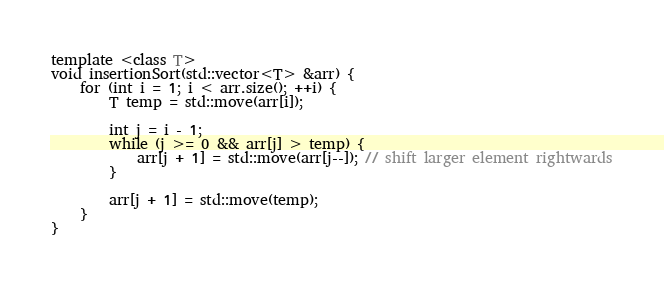<code> <loc_0><loc_0><loc_500><loc_500><_C++_>template <class T>
void insertionSort(std::vector<T> &arr) {
    for (int i = 1; i < arr.size(); ++i) {
        T temp = std::move(arr[i]);

        int j = i - 1;
        while (j >= 0 && arr[j] > temp) {
            arr[j + 1] = std::move(arr[j--]); // shift larger element rightwards
        }

        arr[j + 1] = std::move(temp);
    }
}
</code> 